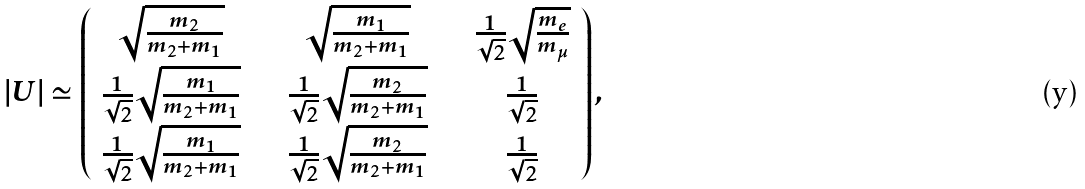<formula> <loc_0><loc_0><loc_500><loc_500>| U | \simeq \left ( \begin{array} { c c c } \sqrt { \frac { m _ { 2 } } { m _ { 2 } + m _ { 1 } } } \quad & \sqrt { \frac { m _ { 1 } } { m _ { 2 } + m _ { 1 } } } \quad & \frac { 1 } { \sqrt { 2 } } \sqrt { \frac { m _ { e } } { m _ { \mu } } } \\ \frac { 1 } { \sqrt { 2 } } \sqrt { \frac { m _ { 1 } } { m _ { 2 } + m _ { 1 } } } \quad & \frac { 1 } { \sqrt { 2 } } \sqrt { \frac { m _ { 2 } } { m _ { 2 } + m _ { 1 } } } \quad & \frac { 1 } { \sqrt { 2 } } \\ \frac { 1 } { \sqrt { 2 } } \sqrt { \frac { m _ { 1 } } { m _ { 2 } + m _ { 1 } } } \quad & \frac { 1 } { \sqrt { 2 } } \sqrt { \frac { m _ { 2 } } { m _ { 2 } + m _ { 1 } } } \quad & \frac { 1 } { \sqrt { 2 } } \\ \end{array} \right ) ,</formula> 